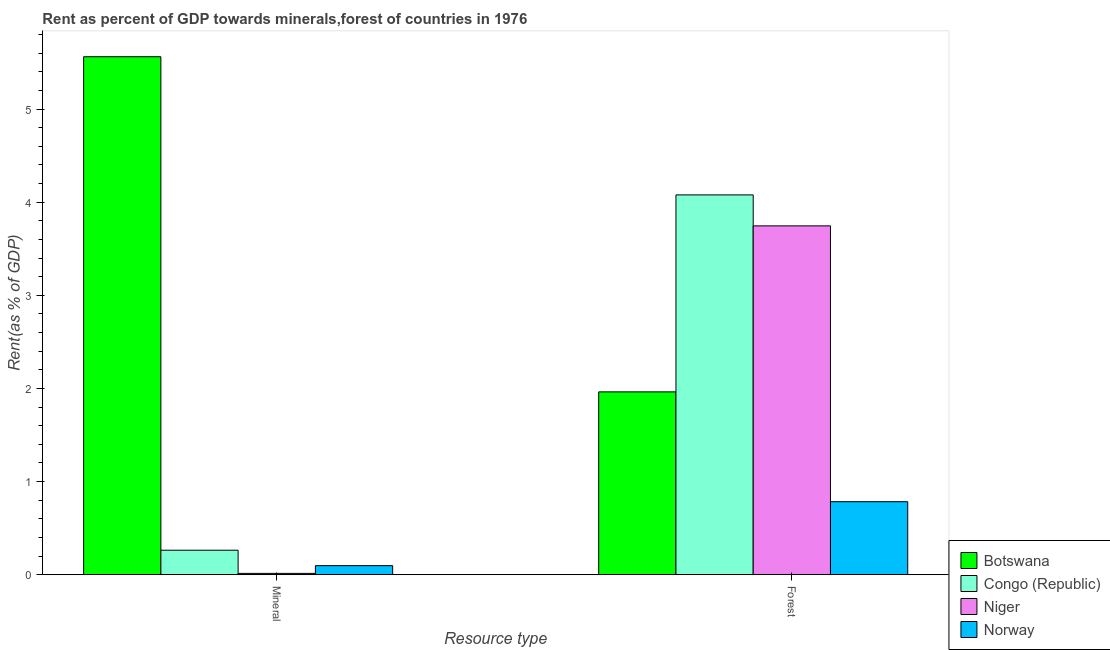Are the number of bars per tick equal to the number of legend labels?
Provide a succinct answer. Yes. Are the number of bars on each tick of the X-axis equal?
Your response must be concise. Yes. How many bars are there on the 1st tick from the left?
Make the answer very short. 4. How many bars are there on the 2nd tick from the right?
Provide a succinct answer. 4. What is the label of the 2nd group of bars from the left?
Offer a terse response. Forest. What is the forest rent in Norway?
Your answer should be compact. 0.78. Across all countries, what is the maximum mineral rent?
Your answer should be very brief. 5.56. Across all countries, what is the minimum forest rent?
Your response must be concise. 0.78. In which country was the mineral rent maximum?
Offer a terse response. Botswana. In which country was the mineral rent minimum?
Your answer should be compact. Niger. What is the total mineral rent in the graph?
Your answer should be very brief. 5.94. What is the difference between the mineral rent in Niger and that in Norway?
Your response must be concise. -0.08. What is the difference between the mineral rent in Congo (Republic) and the forest rent in Botswana?
Your response must be concise. -1.7. What is the average mineral rent per country?
Provide a short and direct response. 1.48. What is the difference between the mineral rent and forest rent in Niger?
Provide a short and direct response. -3.73. What is the ratio of the forest rent in Norway to that in Congo (Republic)?
Your response must be concise. 0.19. Is the mineral rent in Norway less than that in Niger?
Give a very brief answer. No. What does the 1st bar from the left in Forest represents?
Provide a succinct answer. Botswana. What does the 4th bar from the right in Mineral represents?
Offer a terse response. Botswana. How many bars are there?
Give a very brief answer. 8. How many countries are there in the graph?
Make the answer very short. 4. What is the difference between two consecutive major ticks on the Y-axis?
Your answer should be very brief. 1. Does the graph contain any zero values?
Keep it short and to the point. No. Where does the legend appear in the graph?
Offer a terse response. Bottom right. How are the legend labels stacked?
Provide a succinct answer. Vertical. What is the title of the graph?
Give a very brief answer. Rent as percent of GDP towards minerals,forest of countries in 1976. What is the label or title of the X-axis?
Provide a succinct answer. Resource type. What is the label or title of the Y-axis?
Give a very brief answer. Rent(as % of GDP). What is the Rent(as % of GDP) of Botswana in Mineral?
Your response must be concise. 5.56. What is the Rent(as % of GDP) of Congo (Republic) in Mineral?
Your response must be concise. 0.26. What is the Rent(as % of GDP) of Niger in Mineral?
Give a very brief answer. 0.01. What is the Rent(as % of GDP) of Norway in Mineral?
Keep it short and to the point. 0.1. What is the Rent(as % of GDP) in Botswana in Forest?
Give a very brief answer. 1.96. What is the Rent(as % of GDP) of Congo (Republic) in Forest?
Provide a short and direct response. 4.08. What is the Rent(as % of GDP) in Niger in Forest?
Make the answer very short. 3.75. What is the Rent(as % of GDP) in Norway in Forest?
Make the answer very short. 0.78. Across all Resource type, what is the maximum Rent(as % of GDP) in Botswana?
Make the answer very short. 5.56. Across all Resource type, what is the maximum Rent(as % of GDP) in Congo (Republic)?
Give a very brief answer. 4.08. Across all Resource type, what is the maximum Rent(as % of GDP) in Niger?
Your response must be concise. 3.75. Across all Resource type, what is the maximum Rent(as % of GDP) of Norway?
Offer a very short reply. 0.78. Across all Resource type, what is the minimum Rent(as % of GDP) in Botswana?
Keep it short and to the point. 1.96. Across all Resource type, what is the minimum Rent(as % of GDP) of Congo (Republic)?
Offer a very short reply. 0.26. Across all Resource type, what is the minimum Rent(as % of GDP) of Niger?
Offer a very short reply. 0.01. Across all Resource type, what is the minimum Rent(as % of GDP) in Norway?
Your response must be concise. 0.1. What is the total Rent(as % of GDP) in Botswana in the graph?
Your answer should be very brief. 7.53. What is the total Rent(as % of GDP) in Congo (Republic) in the graph?
Give a very brief answer. 4.34. What is the total Rent(as % of GDP) of Niger in the graph?
Your answer should be very brief. 3.76. What is the total Rent(as % of GDP) in Norway in the graph?
Offer a very short reply. 0.88. What is the difference between the Rent(as % of GDP) in Botswana in Mineral and that in Forest?
Your answer should be very brief. 3.6. What is the difference between the Rent(as % of GDP) of Congo (Republic) in Mineral and that in Forest?
Offer a terse response. -3.82. What is the difference between the Rent(as % of GDP) in Niger in Mineral and that in Forest?
Your answer should be very brief. -3.73. What is the difference between the Rent(as % of GDP) of Norway in Mineral and that in Forest?
Provide a succinct answer. -0.69. What is the difference between the Rent(as % of GDP) in Botswana in Mineral and the Rent(as % of GDP) in Congo (Republic) in Forest?
Your answer should be compact. 1.48. What is the difference between the Rent(as % of GDP) of Botswana in Mineral and the Rent(as % of GDP) of Niger in Forest?
Provide a succinct answer. 1.82. What is the difference between the Rent(as % of GDP) of Botswana in Mineral and the Rent(as % of GDP) of Norway in Forest?
Your answer should be very brief. 4.78. What is the difference between the Rent(as % of GDP) in Congo (Republic) in Mineral and the Rent(as % of GDP) in Niger in Forest?
Make the answer very short. -3.48. What is the difference between the Rent(as % of GDP) of Congo (Republic) in Mineral and the Rent(as % of GDP) of Norway in Forest?
Provide a succinct answer. -0.52. What is the difference between the Rent(as % of GDP) in Niger in Mineral and the Rent(as % of GDP) in Norway in Forest?
Keep it short and to the point. -0.77. What is the average Rent(as % of GDP) of Botswana per Resource type?
Keep it short and to the point. 3.76. What is the average Rent(as % of GDP) in Congo (Republic) per Resource type?
Keep it short and to the point. 2.17. What is the average Rent(as % of GDP) of Niger per Resource type?
Offer a very short reply. 1.88. What is the average Rent(as % of GDP) in Norway per Resource type?
Offer a very short reply. 0.44. What is the difference between the Rent(as % of GDP) in Botswana and Rent(as % of GDP) in Congo (Republic) in Mineral?
Your answer should be compact. 5.3. What is the difference between the Rent(as % of GDP) of Botswana and Rent(as % of GDP) of Niger in Mineral?
Offer a very short reply. 5.55. What is the difference between the Rent(as % of GDP) of Botswana and Rent(as % of GDP) of Norway in Mineral?
Ensure brevity in your answer.  5.47. What is the difference between the Rent(as % of GDP) in Congo (Republic) and Rent(as % of GDP) in Niger in Mineral?
Keep it short and to the point. 0.25. What is the difference between the Rent(as % of GDP) of Congo (Republic) and Rent(as % of GDP) of Norway in Mineral?
Keep it short and to the point. 0.17. What is the difference between the Rent(as % of GDP) in Niger and Rent(as % of GDP) in Norway in Mineral?
Offer a terse response. -0.08. What is the difference between the Rent(as % of GDP) in Botswana and Rent(as % of GDP) in Congo (Republic) in Forest?
Ensure brevity in your answer.  -2.12. What is the difference between the Rent(as % of GDP) in Botswana and Rent(as % of GDP) in Niger in Forest?
Make the answer very short. -1.78. What is the difference between the Rent(as % of GDP) of Botswana and Rent(as % of GDP) of Norway in Forest?
Your answer should be compact. 1.18. What is the difference between the Rent(as % of GDP) of Congo (Republic) and Rent(as % of GDP) of Niger in Forest?
Keep it short and to the point. 0.33. What is the difference between the Rent(as % of GDP) in Congo (Republic) and Rent(as % of GDP) in Norway in Forest?
Your answer should be very brief. 3.29. What is the difference between the Rent(as % of GDP) of Niger and Rent(as % of GDP) of Norway in Forest?
Your answer should be very brief. 2.96. What is the ratio of the Rent(as % of GDP) of Botswana in Mineral to that in Forest?
Your answer should be very brief. 2.83. What is the ratio of the Rent(as % of GDP) in Congo (Republic) in Mineral to that in Forest?
Give a very brief answer. 0.06. What is the ratio of the Rent(as % of GDP) in Niger in Mineral to that in Forest?
Give a very brief answer. 0. What is the ratio of the Rent(as % of GDP) of Norway in Mineral to that in Forest?
Ensure brevity in your answer.  0.12. What is the difference between the highest and the second highest Rent(as % of GDP) of Botswana?
Offer a very short reply. 3.6. What is the difference between the highest and the second highest Rent(as % of GDP) of Congo (Republic)?
Your response must be concise. 3.82. What is the difference between the highest and the second highest Rent(as % of GDP) in Niger?
Your answer should be very brief. 3.73. What is the difference between the highest and the second highest Rent(as % of GDP) in Norway?
Your answer should be compact. 0.69. What is the difference between the highest and the lowest Rent(as % of GDP) of Botswana?
Your answer should be very brief. 3.6. What is the difference between the highest and the lowest Rent(as % of GDP) in Congo (Republic)?
Keep it short and to the point. 3.82. What is the difference between the highest and the lowest Rent(as % of GDP) in Niger?
Your response must be concise. 3.73. What is the difference between the highest and the lowest Rent(as % of GDP) of Norway?
Your answer should be very brief. 0.69. 